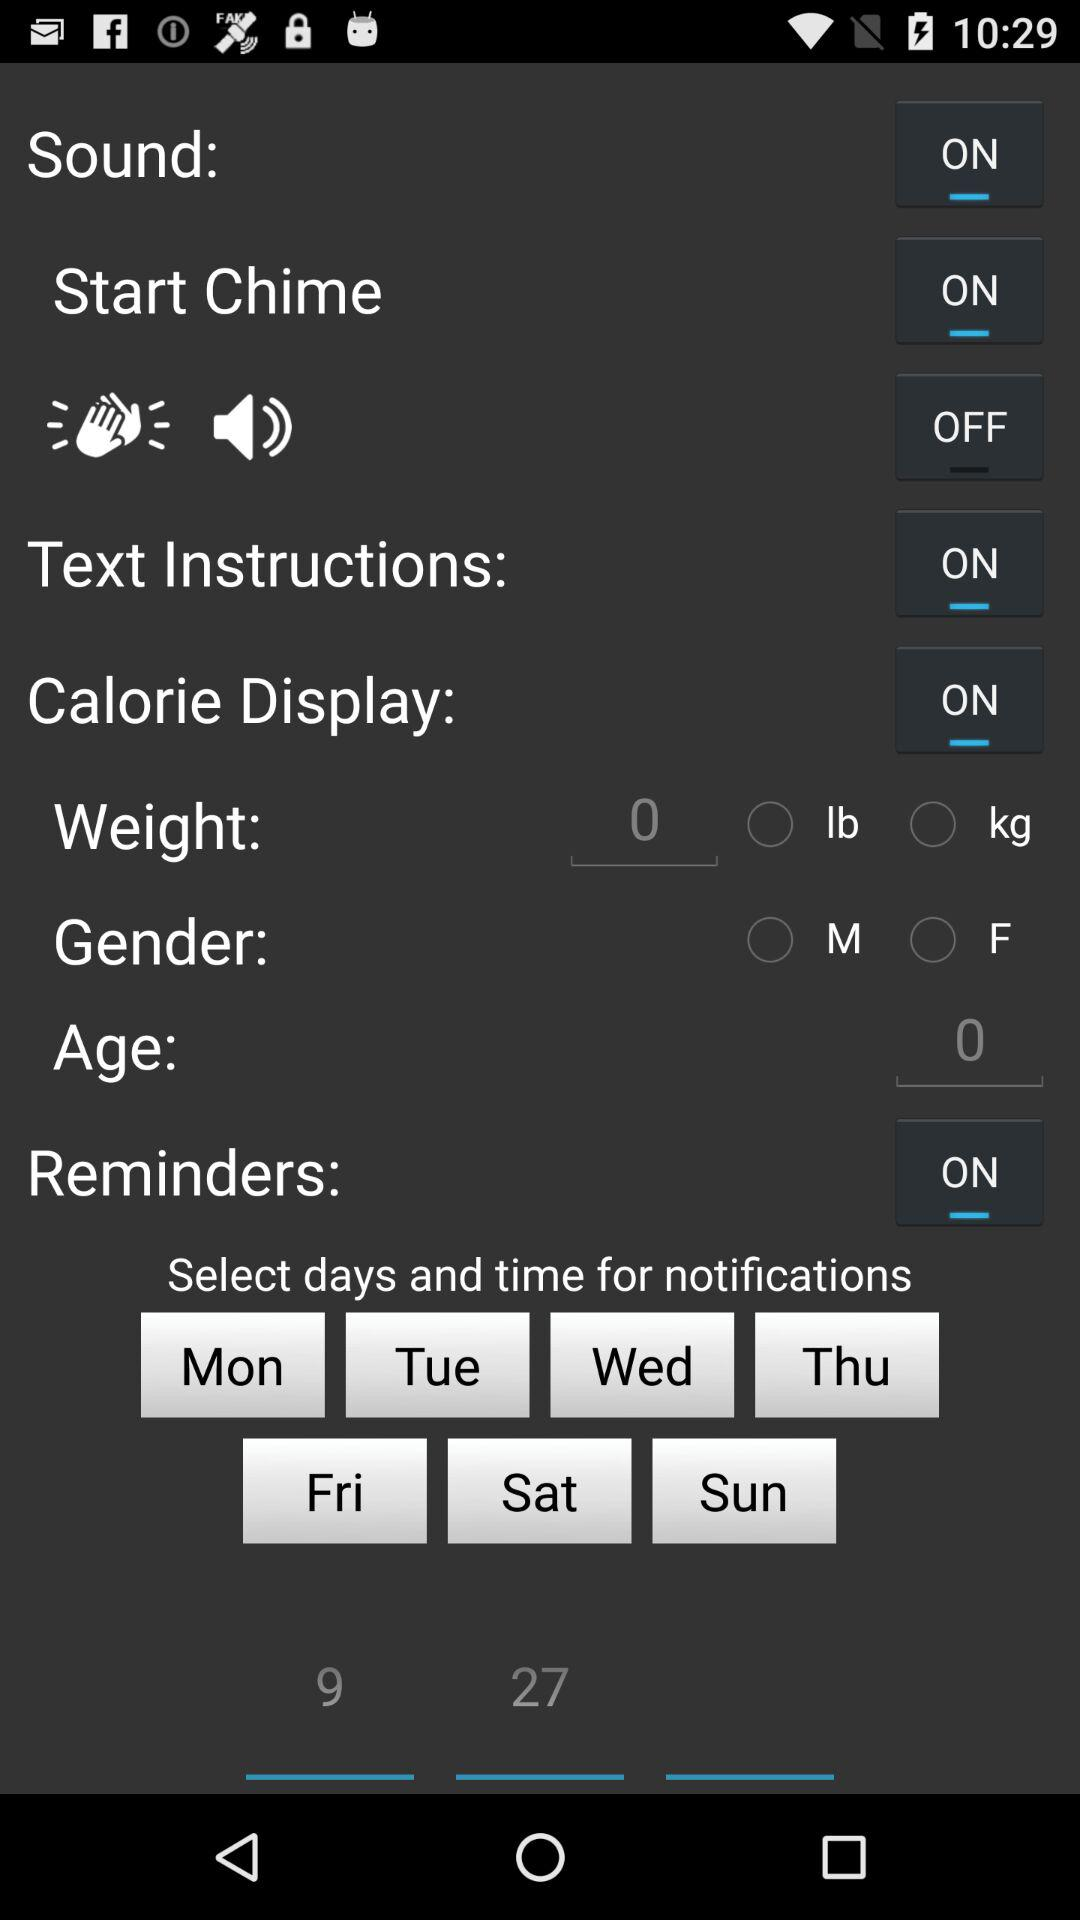How many text inputs are there for the age field?
Answer the question using a single word or phrase. 1 